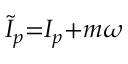<formula> <loc_0><loc_0><loc_500><loc_500>\widetilde { I } _ { p } { = } I _ { p } { + } m \omega</formula> 